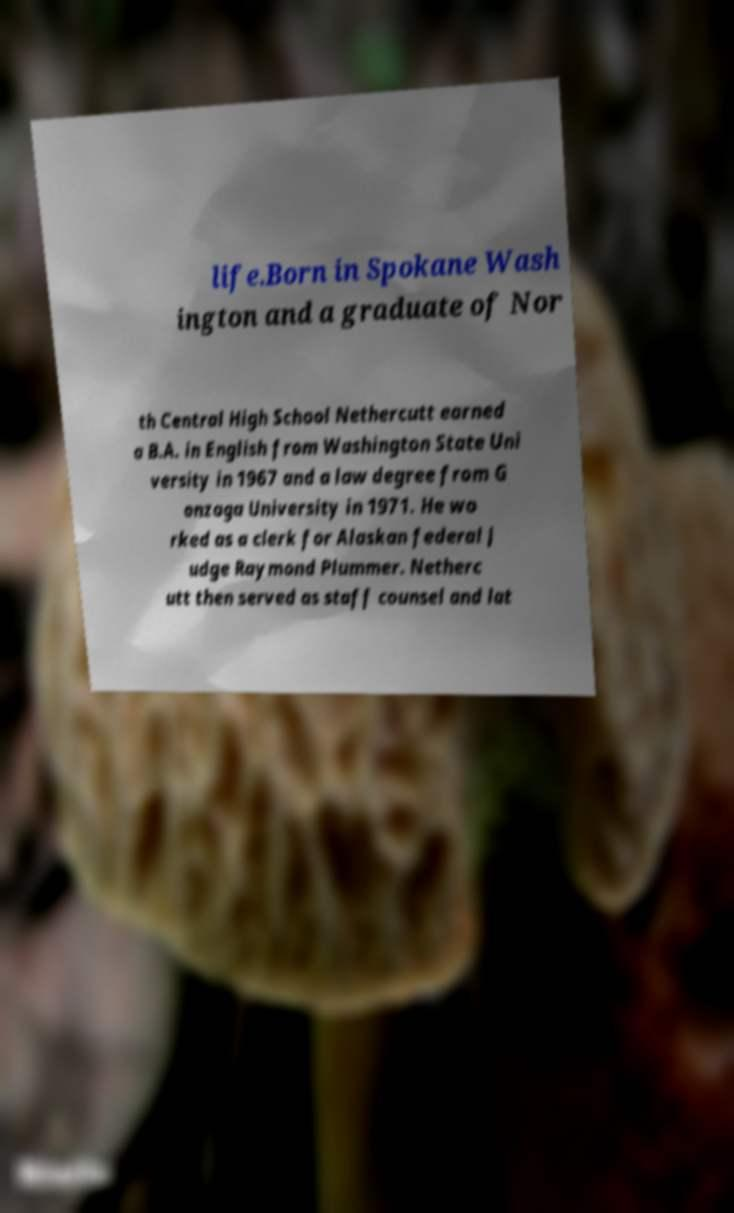What messages or text are displayed in this image? I need them in a readable, typed format. life.Born in Spokane Wash ington and a graduate of Nor th Central High School Nethercutt earned a B.A. in English from Washington State Uni versity in 1967 and a law degree from G onzaga University in 1971. He wo rked as a clerk for Alaskan federal J udge Raymond Plummer. Netherc utt then served as staff counsel and lat 